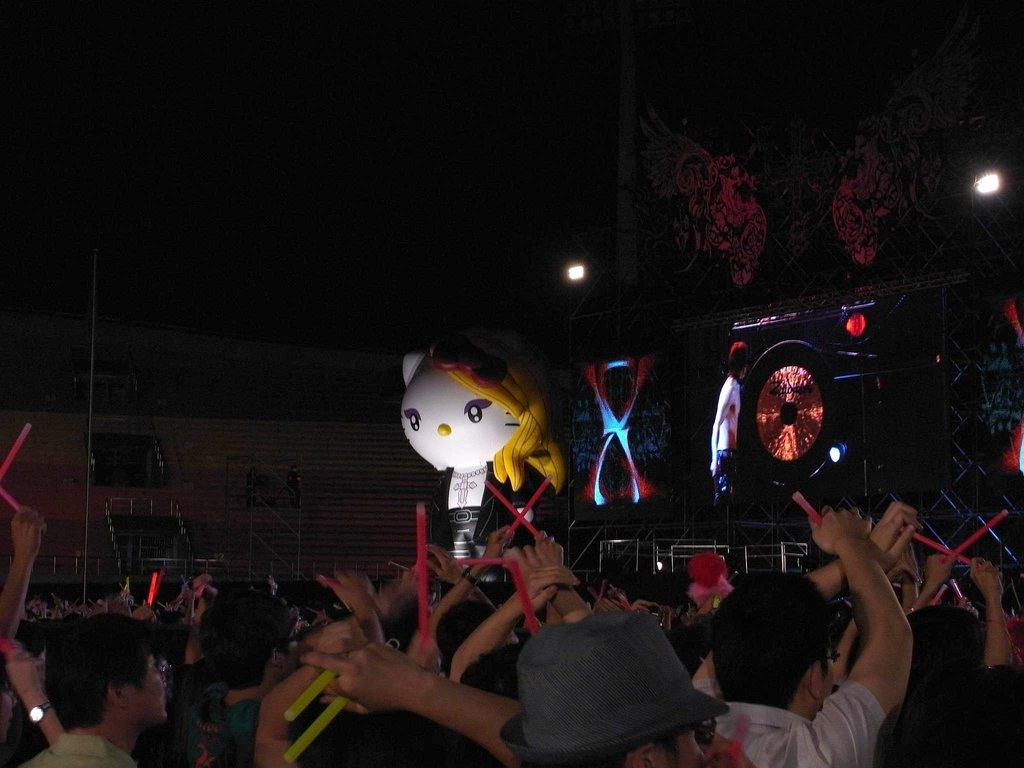What type of structure is the main subject of the image? There is a stadium in the image. What are the groups of people holding in the image? The groups of people are holding objects in the image. Can you describe the mascot in the image? There is a mascot in the image. What type of display can be seen in the image? There is a screen in the image. What can be seen illuminating the scene in the image? There are lights in the image. How would you describe the overall lighting in the image? The background of the image is dark. What flavor of ice cream is the grandfather enjoying in the image? There is no ice cream or grandfather present in the image. How does the mascot push the screen in the image? The mascot does not push the screen in the image; they are separate elements within the scene. 